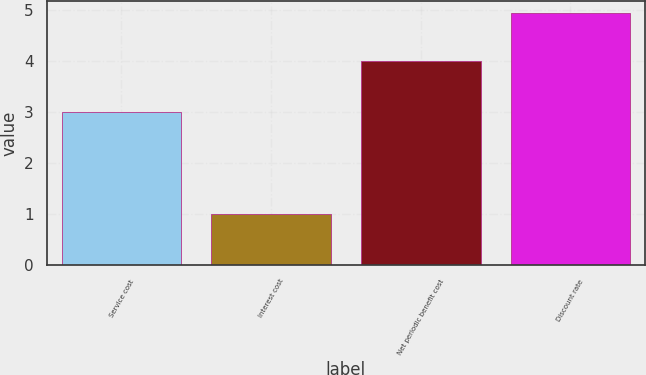<chart> <loc_0><loc_0><loc_500><loc_500><bar_chart><fcel>Service cost<fcel>Interest cost<fcel>Net periodic benefit cost<fcel>Discount rate<nl><fcel>3<fcel>1<fcel>4<fcel>4.93<nl></chart> 